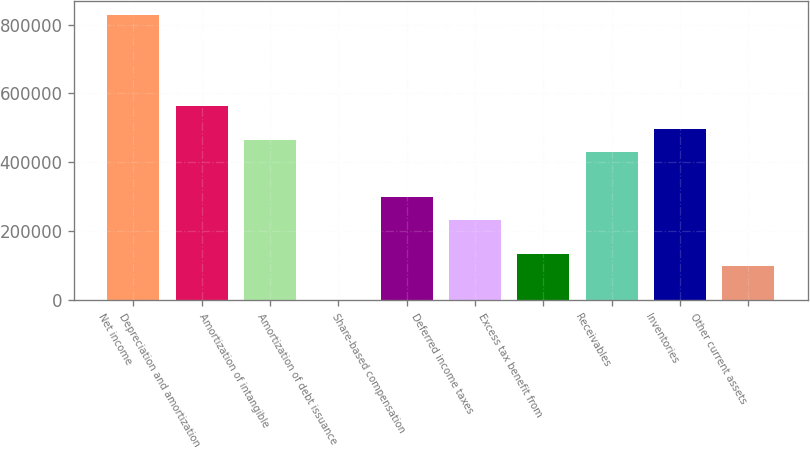Convert chart to OTSL. <chart><loc_0><loc_0><loc_500><loc_500><bar_chart><fcel>Net income<fcel>Depreciation and amortization<fcel>Amortization of intangible<fcel>Amortization of debt issuance<fcel>Share-based compensation<fcel>Deferred income taxes<fcel>Excess tax benefit from<fcel>Receivables<fcel>Inventories<fcel>Other current assets<nl><fcel>828260<fcel>563392<fcel>464066<fcel>547<fcel>298524<fcel>232306<fcel>132981<fcel>430958<fcel>497174<fcel>99872.5<nl></chart> 